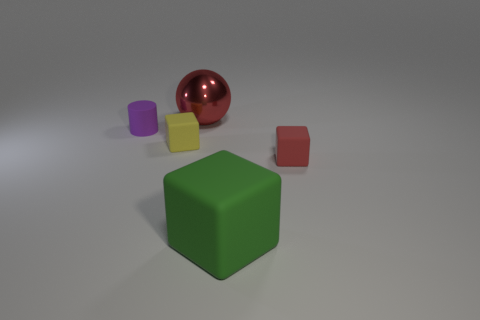Subtract all balls. How many objects are left? 4 Subtract 1 balls. How many balls are left? 0 Subtract all gray balls. Subtract all blue cylinders. How many balls are left? 1 Subtract all green balls. How many red cubes are left? 1 Subtract all gray things. Subtract all purple cylinders. How many objects are left? 4 Add 5 large red balls. How many large red balls are left? 6 Add 1 large blue cylinders. How many large blue cylinders exist? 1 Add 3 brown matte cubes. How many objects exist? 8 Subtract all red blocks. How many blocks are left? 2 Subtract all small rubber cubes. How many cubes are left? 1 